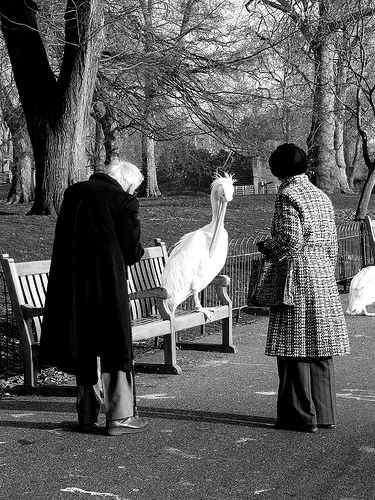Please provide the bounding box coordinate of the region this sentence describes: Large black and white purse a woman is holding. [0.62, 0.51, 0.72, 0.62] 